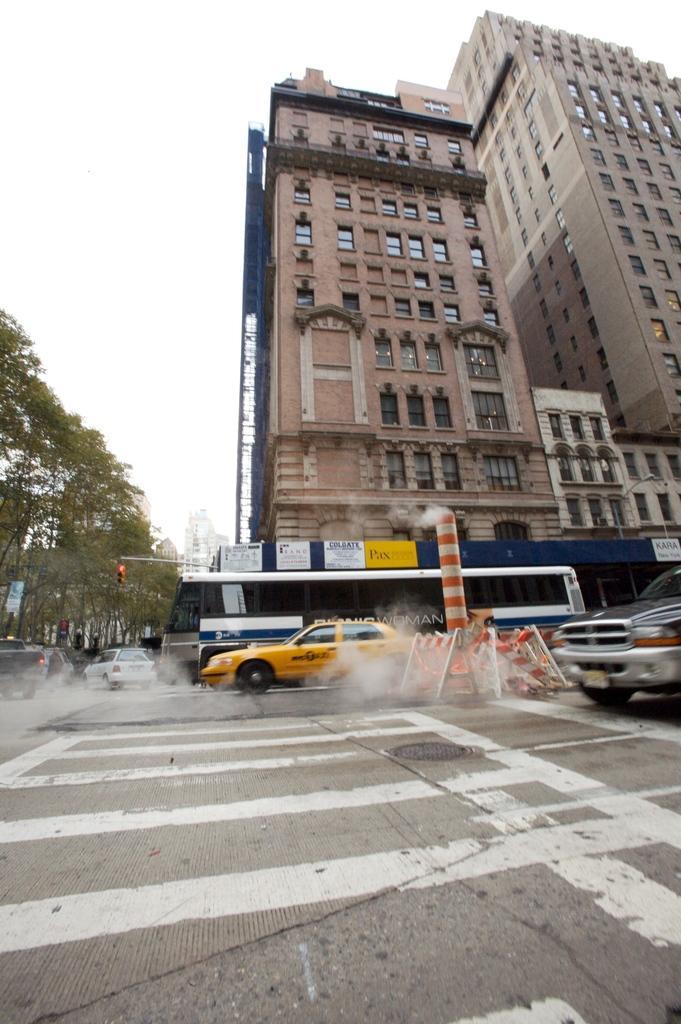Please provide a concise description of this image. In the picture we can see the surface of the road with zebra lines and on it we can see a part of the car and beside it, we can see a pole and a car, bus and beside it, we can see two buildings with windows and opposite side of it we can see some trees and in the background we can see the sky. 